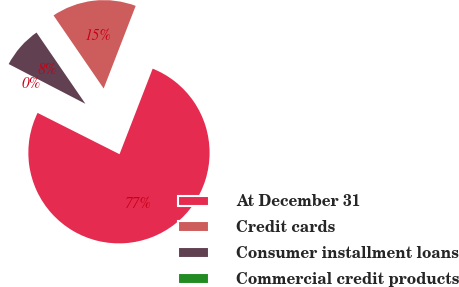Convert chart. <chart><loc_0><loc_0><loc_500><loc_500><pie_chart><fcel>At December 31<fcel>Credit cards<fcel>Consumer installment loans<fcel>Commercial credit products<nl><fcel>76.54%<fcel>15.45%<fcel>7.82%<fcel>0.18%<nl></chart> 